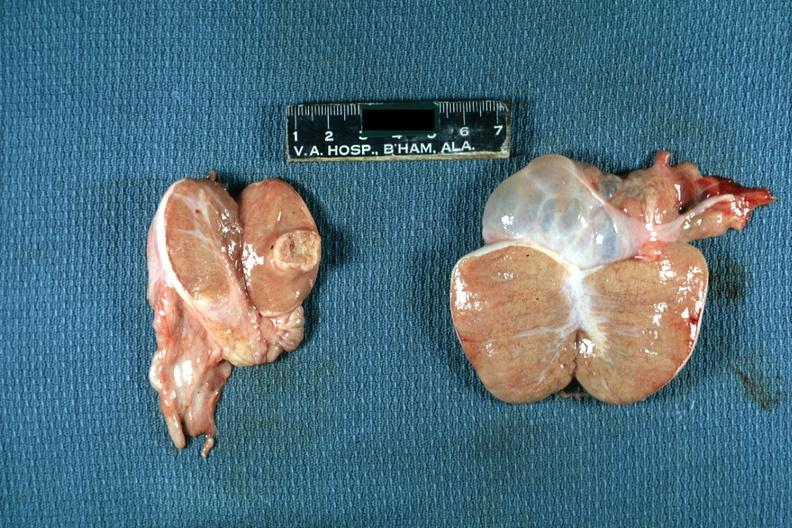does this image show discrete yellow mass lesion in one testicle hydrocele in other?
Answer the question using a single word or phrase. Yes 